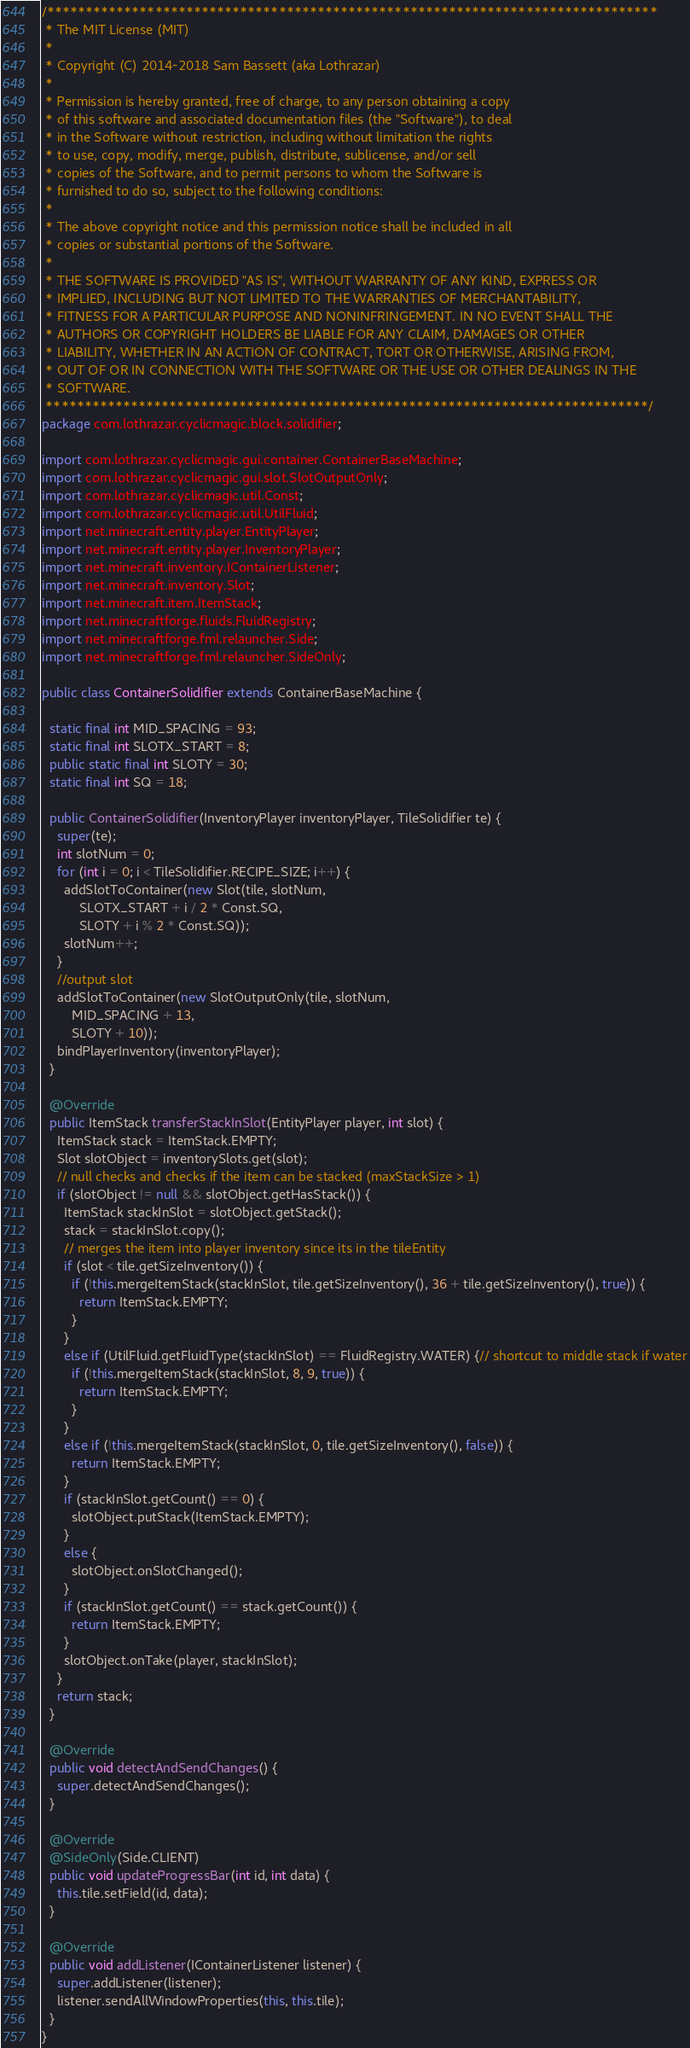<code> <loc_0><loc_0><loc_500><loc_500><_Java_>/*******************************************************************************
 * The MIT License (MIT)
 * 
 * Copyright (C) 2014-2018 Sam Bassett (aka Lothrazar)
 * 
 * Permission is hereby granted, free of charge, to any person obtaining a copy
 * of this software and associated documentation files (the "Software"), to deal
 * in the Software without restriction, including without limitation the rights
 * to use, copy, modify, merge, publish, distribute, sublicense, and/or sell
 * copies of the Software, and to permit persons to whom the Software is
 * furnished to do so, subject to the following conditions:
 * 
 * The above copyright notice and this permission notice shall be included in all
 * copies or substantial portions of the Software.
 * 
 * THE SOFTWARE IS PROVIDED "AS IS", WITHOUT WARRANTY OF ANY KIND, EXPRESS OR
 * IMPLIED, INCLUDING BUT NOT LIMITED TO THE WARRANTIES OF MERCHANTABILITY,
 * FITNESS FOR A PARTICULAR PURPOSE AND NONINFRINGEMENT. IN NO EVENT SHALL THE
 * AUTHORS OR COPYRIGHT HOLDERS BE LIABLE FOR ANY CLAIM, DAMAGES OR OTHER
 * LIABILITY, WHETHER IN AN ACTION OF CONTRACT, TORT OR OTHERWISE, ARISING FROM,
 * OUT OF OR IN CONNECTION WITH THE SOFTWARE OR THE USE OR OTHER DEALINGS IN THE
 * SOFTWARE.
 ******************************************************************************/
package com.lothrazar.cyclicmagic.block.solidifier;

import com.lothrazar.cyclicmagic.gui.container.ContainerBaseMachine;
import com.lothrazar.cyclicmagic.gui.slot.SlotOutputOnly;
import com.lothrazar.cyclicmagic.util.Const;
import com.lothrazar.cyclicmagic.util.UtilFluid;
import net.minecraft.entity.player.EntityPlayer;
import net.minecraft.entity.player.InventoryPlayer;
import net.minecraft.inventory.IContainerListener;
import net.minecraft.inventory.Slot;
import net.minecraft.item.ItemStack;
import net.minecraftforge.fluids.FluidRegistry;
import net.minecraftforge.fml.relauncher.Side;
import net.minecraftforge.fml.relauncher.SideOnly;

public class ContainerSolidifier extends ContainerBaseMachine {

  static final int MID_SPACING = 93;
  static final int SLOTX_START = 8;
  public static final int SLOTY = 30;
  static final int SQ = 18;

  public ContainerSolidifier(InventoryPlayer inventoryPlayer, TileSolidifier te) {
    super(te);
    int slotNum = 0;
    for (int i = 0; i < TileSolidifier.RECIPE_SIZE; i++) {
      addSlotToContainer(new Slot(tile, slotNum,
          SLOTX_START + i / 2 * Const.SQ,
          SLOTY + i % 2 * Const.SQ));
      slotNum++;
    }
    //output slot
    addSlotToContainer(new SlotOutputOnly(tile, slotNum,
        MID_SPACING + 13,
        SLOTY + 10));
    bindPlayerInventory(inventoryPlayer);
  }

  @Override
  public ItemStack transferStackInSlot(EntityPlayer player, int slot) {
    ItemStack stack = ItemStack.EMPTY;
    Slot slotObject = inventorySlots.get(slot);
    // null checks and checks if the item can be stacked (maxStackSize > 1)
    if (slotObject != null && slotObject.getHasStack()) {
      ItemStack stackInSlot = slotObject.getStack();
      stack = stackInSlot.copy();
      // merges the item into player inventory since its in the tileEntity 
      if (slot < tile.getSizeInventory()) {
        if (!this.mergeItemStack(stackInSlot, tile.getSizeInventory(), 36 + tile.getSizeInventory(), true)) {
          return ItemStack.EMPTY;
        }
      }
      else if (UtilFluid.getFluidType(stackInSlot) == FluidRegistry.WATER) {// shortcut to middle stack if water
        if (!this.mergeItemStack(stackInSlot, 8, 9, true)) {
          return ItemStack.EMPTY;
        }
      }
      else if (!this.mergeItemStack(stackInSlot, 0, tile.getSizeInventory(), false)) {
        return ItemStack.EMPTY;
      }
      if (stackInSlot.getCount() == 0) {
        slotObject.putStack(ItemStack.EMPTY);
      }
      else {
        slotObject.onSlotChanged();
      }
      if (stackInSlot.getCount() == stack.getCount()) {
        return ItemStack.EMPTY;
      }
      slotObject.onTake(player, stackInSlot);
    }
    return stack;
  }

  @Override
  public void detectAndSendChanges() {
    super.detectAndSendChanges();
  }

  @Override
  @SideOnly(Side.CLIENT)
  public void updateProgressBar(int id, int data) {
    this.tile.setField(id, data);
  }

  @Override
  public void addListener(IContainerListener listener) {
    super.addListener(listener);
    listener.sendAllWindowProperties(this, this.tile);
  }
}
</code> 